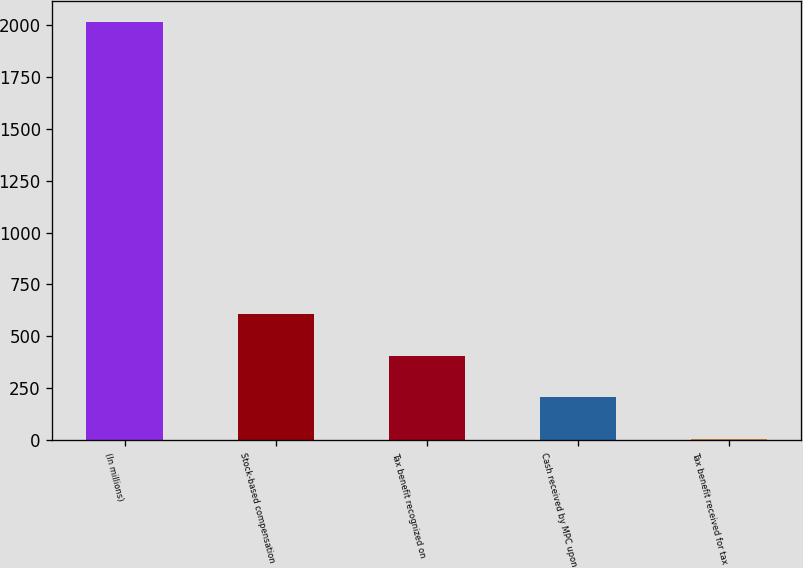Convert chart to OTSL. <chart><loc_0><loc_0><loc_500><loc_500><bar_chart><fcel>(In millions)<fcel>Stock-based compensation<fcel>Tax benefit recognized on<fcel>Cash received by MPC upon<fcel>Tax benefit received for tax<nl><fcel>2016<fcel>607.6<fcel>406.4<fcel>205.2<fcel>4<nl></chart> 